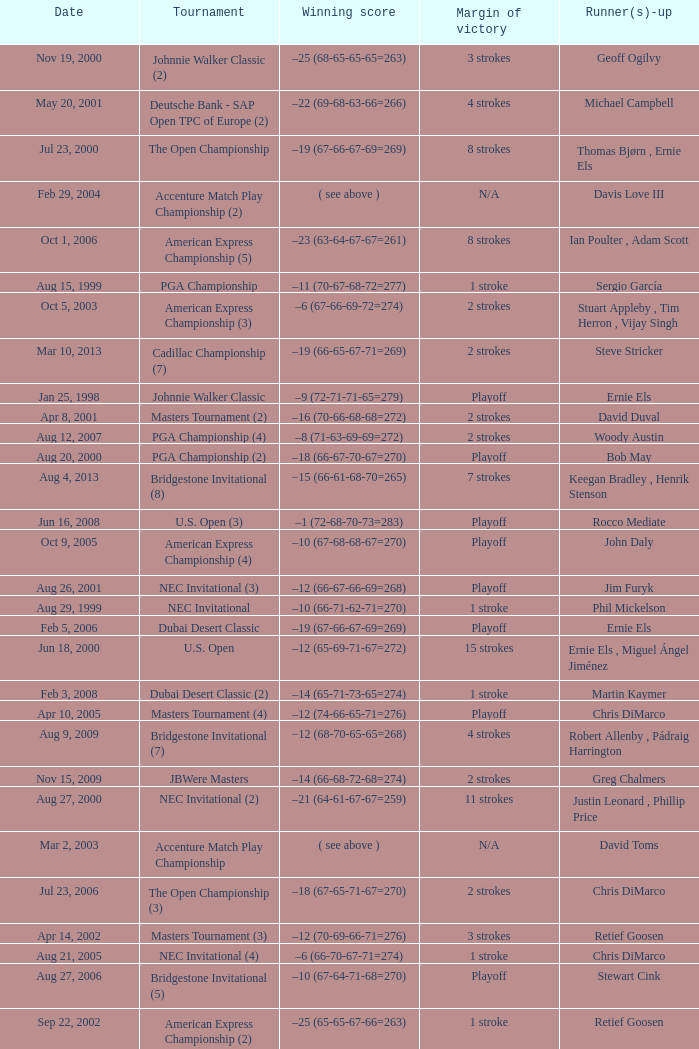Who is Runner(s)-up that has a Date of may 24, 1999? Retief Goosen. 